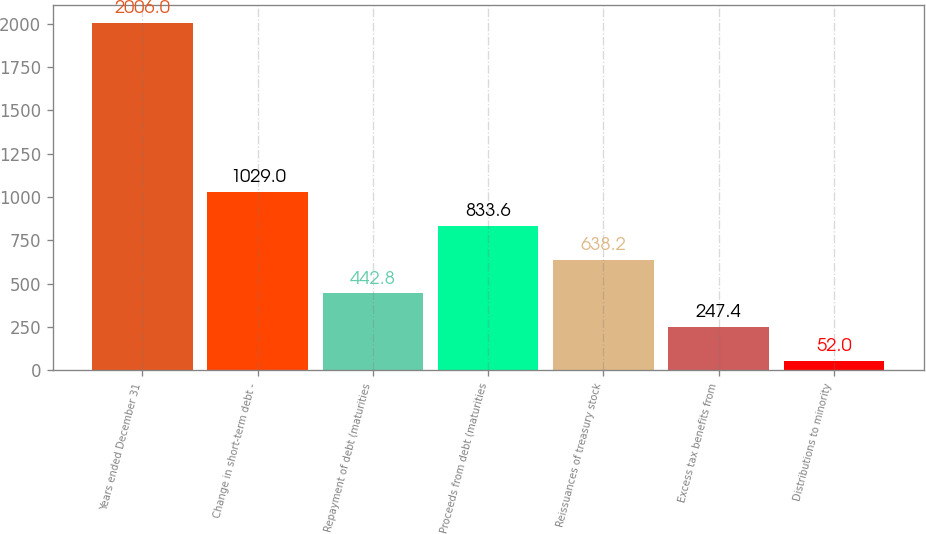<chart> <loc_0><loc_0><loc_500><loc_500><bar_chart><fcel>Years ended December 31<fcel>Change in short-term debt -<fcel>Repayment of debt (maturities<fcel>Proceeds from debt (maturities<fcel>Reissuances of treasury stock<fcel>Excess tax benefits from<fcel>Distributions to minority<nl><fcel>2006<fcel>1029<fcel>442.8<fcel>833.6<fcel>638.2<fcel>247.4<fcel>52<nl></chart> 